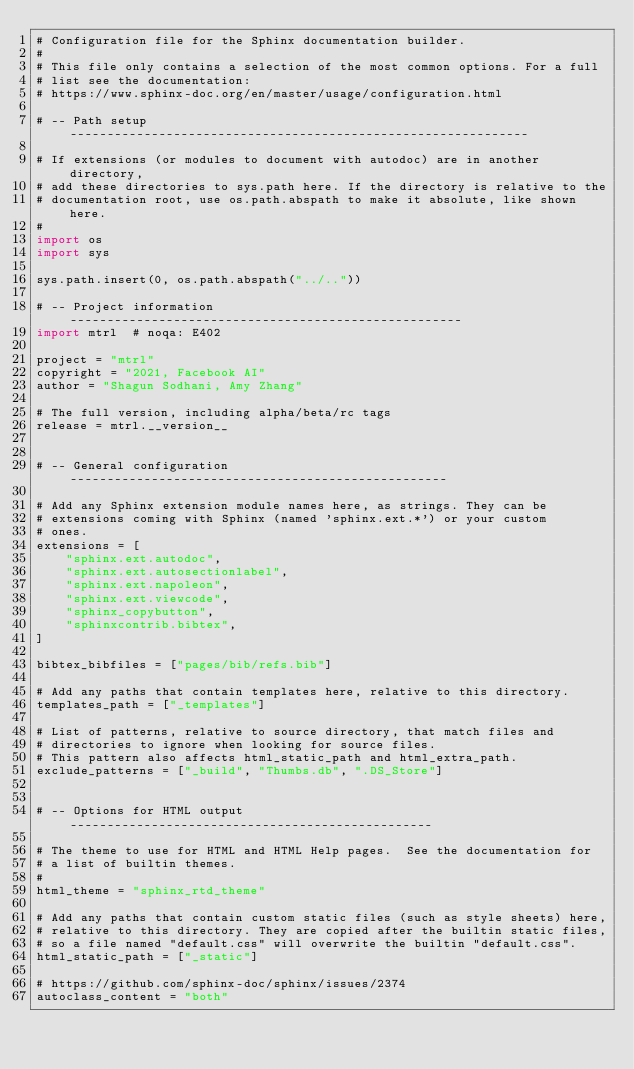<code> <loc_0><loc_0><loc_500><loc_500><_Python_># Configuration file for the Sphinx documentation builder.
#
# This file only contains a selection of the most common options. For a full
# list see the documentation:
# https://www.sphinx-doc.org/en/master/usage/configuration.html

# -- Path setup --------------------------------------------------------------

# If extensions (or modules to document with autodoc) are in another directory,
# add these directories to sys.path here. If the directory is relative to the
# documentation root, use os.path.abspath to make it absolute, like shown here.
#
import os
import sys

sys.path.insert(0, os.path.abspath("../.."))

# -- Project information -----------------------------------------------------
import mtrl  # noqa: E402

project = "mtrl"
copyright = "2021, Facebook AI"
author = "Shagun Sodhani, Amy Zhang"

# The full version, including alpha/beta/rc tags
release = mtrl.__version__


# -- General configuration ---------------------------------------------------

# Add any Sphinx extension module names here, as strings. They can be
# extensions coming with Sphinx (named 'sphinx.ext.*') or your custom
# ones.
extensions = [
    "sphinx.ext.autodoc",
    "sphinx.ext.autosectionlabel",
    "sphinx.ext.napoleon",
    "sphinx.ext.viewcode",
    "sphinx_copybutton",
    "sphinxcontrib.bibtex",
]

bibtex_bibfiles = ["pages/bib/refs.bib"]

# Add any paths that contain templates here, relative to this directory.
templates_path = ["_templates"]

# List of patterns, relative to source directory, that match files and
# directories to ignore when looking for source files.
# This pattern also affects html_static_path and html_extra_path.
exclude_patterns = ["_build", "Thumbs.db", ".DS_Store"]


# -- Options for HTML output -------------------------------------------------

# The theme to use for HTML and HTML Help pages.  See the documentation for
# a list of builtin themes.
#
html_theme = "sphinx_rtd_theme"

# Add any paths that contain custom static files (such as style sheets) here,
# relative to this directory. They are copied after the builtin static files,
# so a file named "default.css" will overwrite the builtin "default.css".
html_static_path = ["_static"]

# https://github.com/sphinx-doc/sphinx/issues/2374
autoclass_content = "both"
</code> 